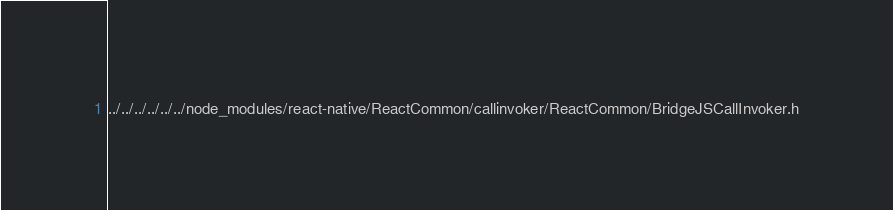Convert code to text. <code><loc_0><loc_0><loc_500><loc_500><_C_>../../../../../../node_modules/react-native/ReactCommon/callinvoker/ReactCommon/BridgeJSCallInvoker.h</code> 